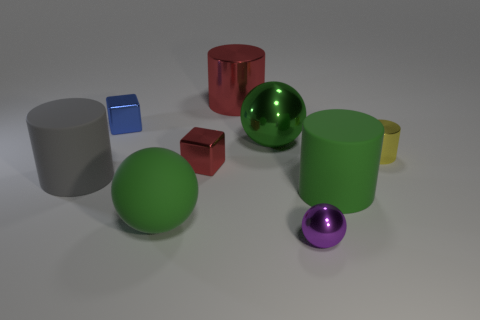Are there fewer red cubes that are on the left side of the big gray object than large red cylinders?
Offer a terse response. Yes. Are there any big yellow rubber things of the same shape as the large red thing?
Your response must be concise. No. There is a yellow metallic thing that is the same size as the purple shiny sphere; what is its shape?
Your answer should be compact. Cylinder. How many objects are tiny gray metallic cylinders or big balls?
Your answer should be very brief. 2. Is there a big blue matte object?
Your response must be concise. No. Is the number of large red rubber objects less than the number of tiny blue objects?
Keep it short and to the point. Yes. Are there any green spheres that have the same size as the yellow cylinder?
Your answer should be very brief. No. Is the shape of the yellow metallic thing the same as the matte thing that is to the right of the red cylinder?
Offer a terse response. Yes. How many blocks are either red shiny objects or big rubber things?
Provide a short and direct response. 1. What is the color of the large metal cylinder?
Provide a succinct answer. Red. 